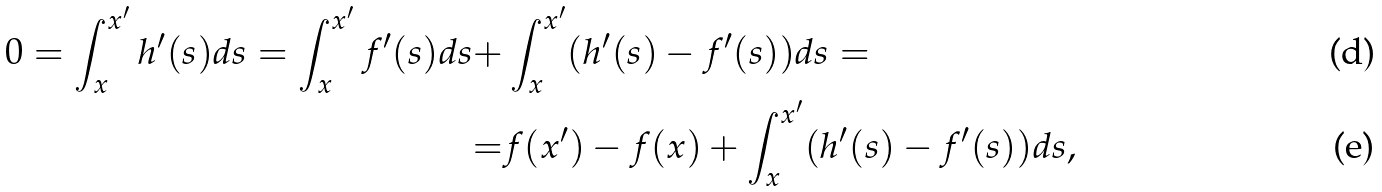Convert formula to latex. <formula><loc_0><loc_0><loc_500><loc_500>0 = \int _ { x } ^ { x ^ { \prime } } h ^ { \prime } ( s ) d s = \int _ { x } ^ { x ^ { \prime } } f ^ { \prime } ( s ) d s + & \int _ { x } ^ { x ^ { \prime } } ( h ^ { \prime } ( s ) - f ^ { \prime } ( s ) ) d s = \\ = & f ( x ^ { \prime } ) - f ( x ) + \int _ { x } ^ { x ^ { \prime } } ( h ^ { \prime } ( s ) - f ^ { \prime } ( s ) ) d s ,</formula> 